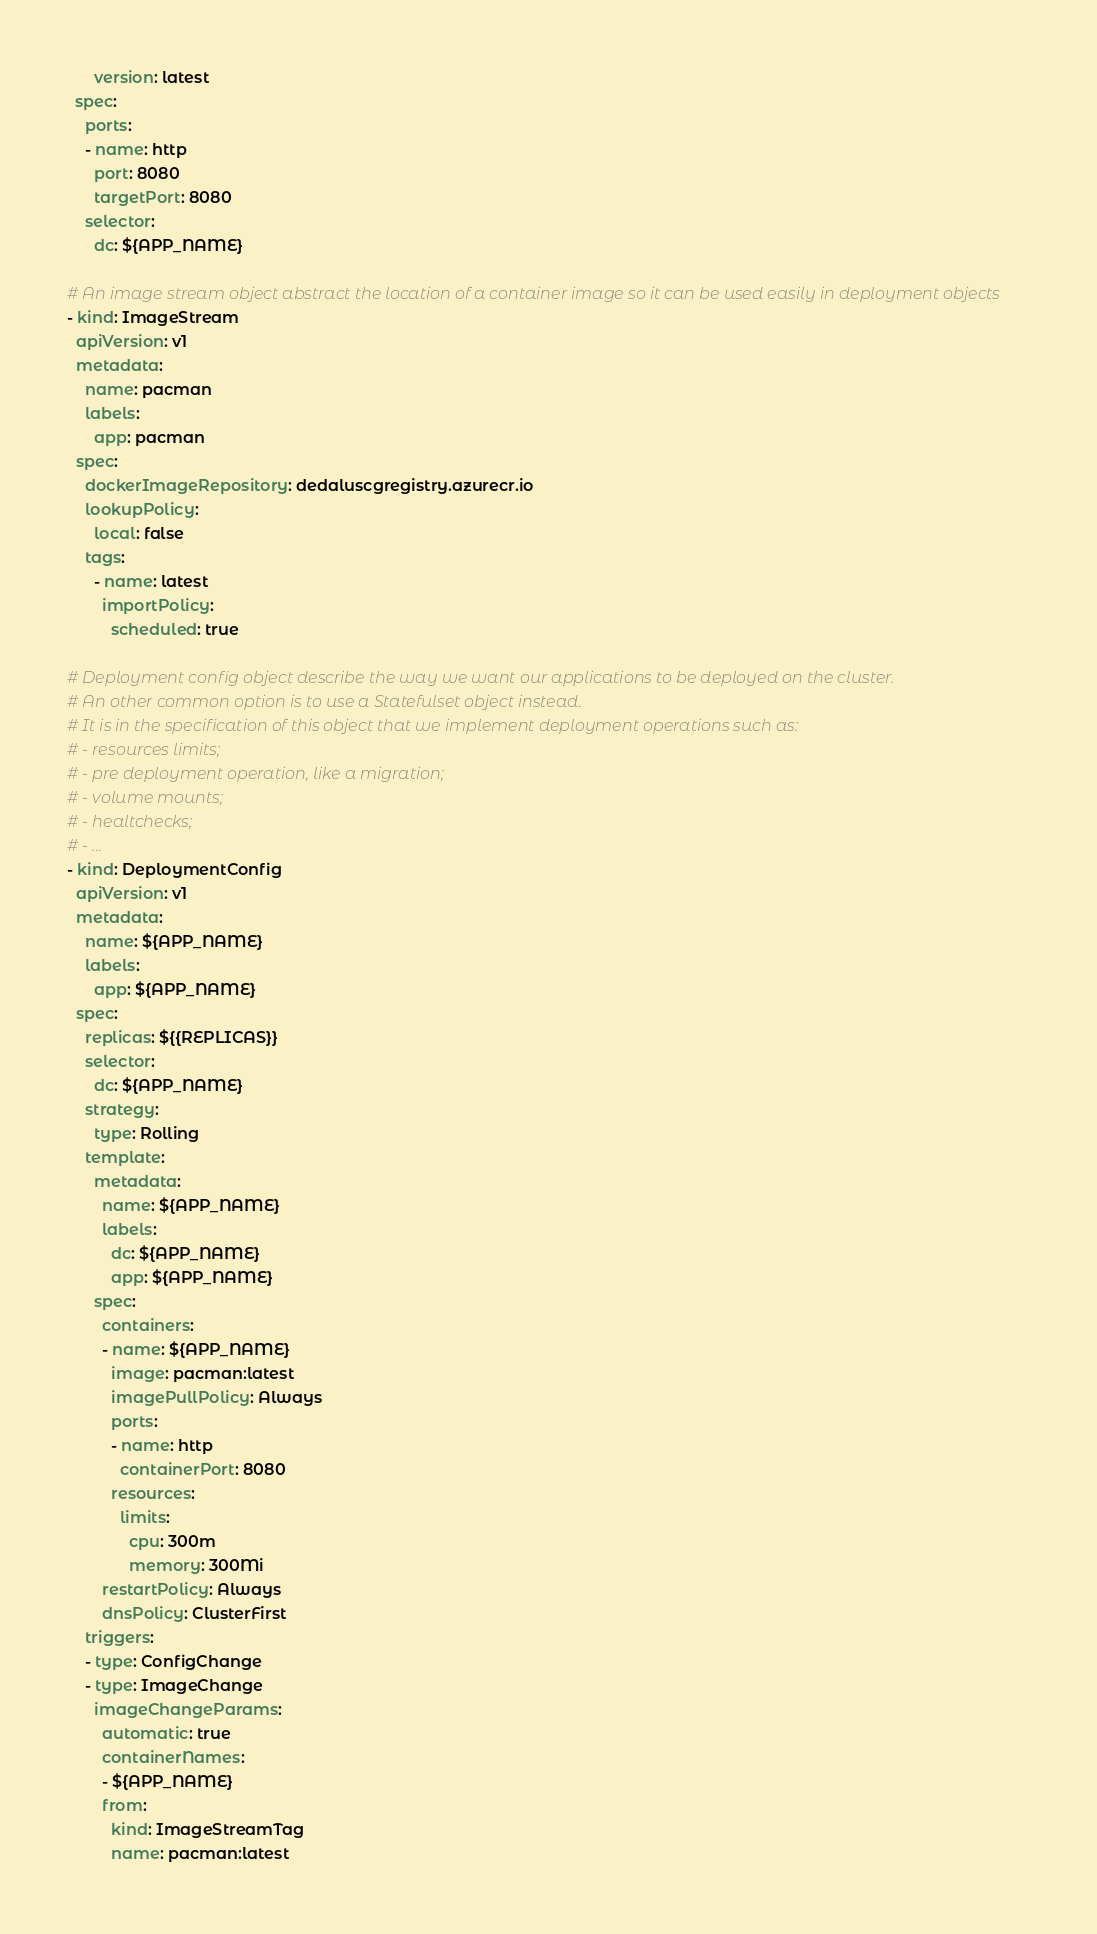Convert code to text. <code><loc_0><loc_0><loc_500><loc_500><_YAML_>      version: latest
  spec:
    ports:
    - name: http
      port: 8080
      targetPort: 8080
    selector:
      dc: ${APP_NAME}

# An image stream object abstract the location of a container image so it can be used easily in deployment objects
- kind: ImageStream
  apiVersion: v1
  metadata:
    name: pacman
    labels:
      app: pacman
  spec:
    dockerImageRepository: dedaluscgregistry.azurecr.io
    lookupPolicy:
      local: false
    tags:
      - name: latest
        importPolicy:
          scheduled: true

# Deployment config object describe the way we want our applications to be deployed on the cluster.
# An other common option is to use a Statefulset object instead.
# It is in the specification of this object that we implement deployment operations such as:
# - resources limits;
# - pre deployment operation, like a migration;
# - volume mounts;
# - healtchecks;
# - ...
- kind: DeploymentConfig
  apiVersion: v1
  metadata:
    name: ${APP_NAME}
    labels:
      app: ${APP_NAME}
  spec:
    replicas: ${{REPLICAS}}
    selector:
      dc: ${APP_NAME}
    strategy:
      type: Rolling
    template:
      metadata:
        name: ${APP_NAME}
        labels:
          dc: ${APP_NAME}
          app: ${APP_NAME}
      spec:
        containers:
        - name: ${APP_NAME}
          image: pacman:latest
          imagePullPolicy: Always
          ports:
          - name: http
            containerPort: 8080
          resources:
            limits:
              cpu: 300m
              memory: 300Mi
        restartPolicy: Always
        dnsPolicy: ClusterFirst
    triggers:
    - type: ConfigChange
    - type: ImageChange
      imageChangeParams:
        automatic: true
        containerNames:
        - ${APP_NAME}
        from:
          kind: ImageStreamTag
          name: pacman:latest</code> 